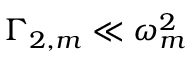<formula> <loc_0><loc_0><loc_500><loc_500>\Gamma _ { 2 , m } \ll \omega _ { m } ^ { 2 }</formula> 